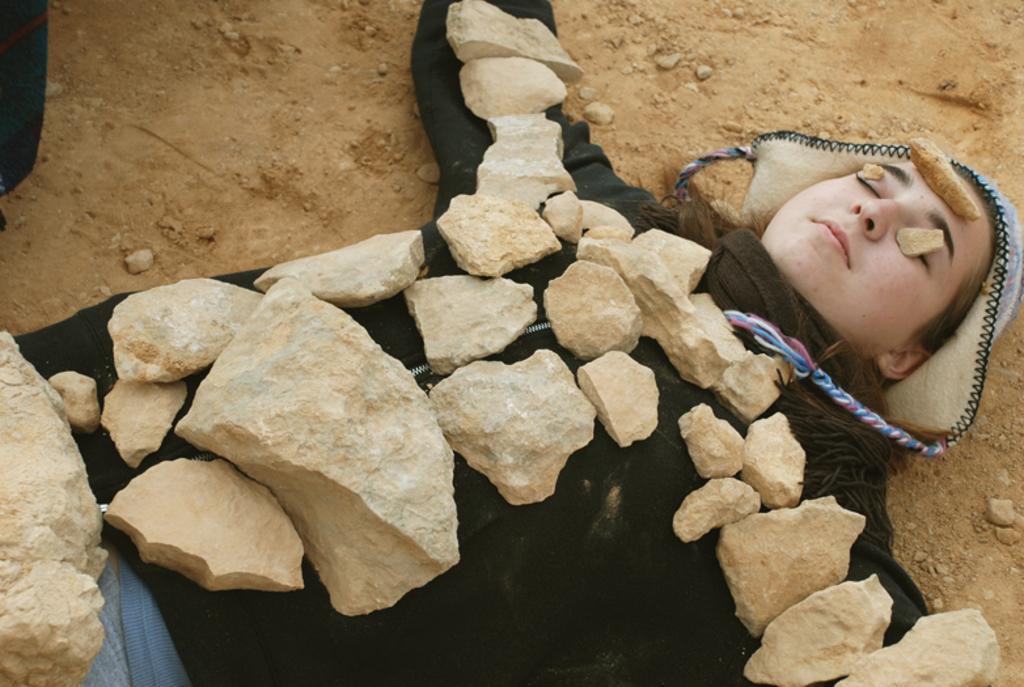How would you summarize this image in a sentence or two? Here in this picture we can see a woman wearing a jacket and laying on the ground and we can see number of stones placed on her. 